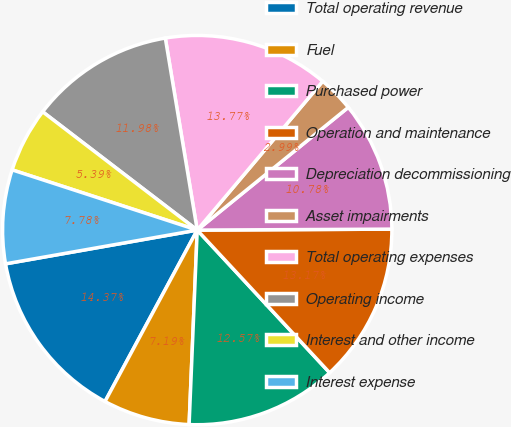<chart> <loc_0><loc_0><loc_500><loc_500><pie_chart><fcel>Total operating revenue<fcel>Fuel<fcel>Purchased power<fcel>Operation and maintenance<fcel>Depreciation decommissioning<fcel>Asset impairments<fcel>Total operating expenses<fcel>Operating income<fcel>Interest and other income<fcel>Interest expense<nl><fcel>14.37%<fcel>7.19%<fcel>12.57%<fcel>13.17%<fcel>10.78%<fcel>2.99%<fcel>13.77%<fcel>11.98%<fcel>5.39%<fcel>7.78%<nl></chart> 